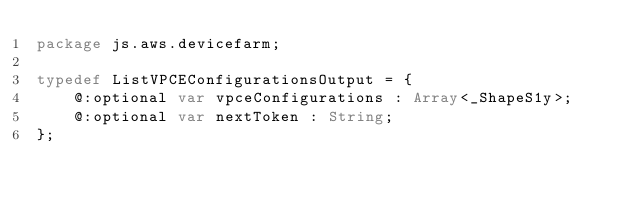Convert code to text. <code><loc_0><loc_0><loc_500><loc_500><_Haxe_>package js.aws.devicefarm;

typedef ListVPCEConfigurationsOutput = {
    @:optional var vpceConfigurations : Array<_ShapeS1y>;
    @:optional var nextToken : String;
};
</code> 